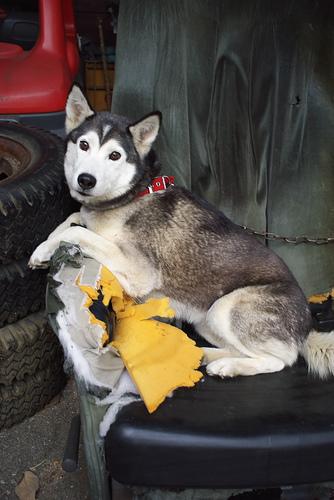What is the dog sitting on?
Write a very short answer. Chair. Was this photo taken outside?
Answer briefly. Yes. Are the animal's ears straight up or floppy?
Answer briefly. Straight up. 